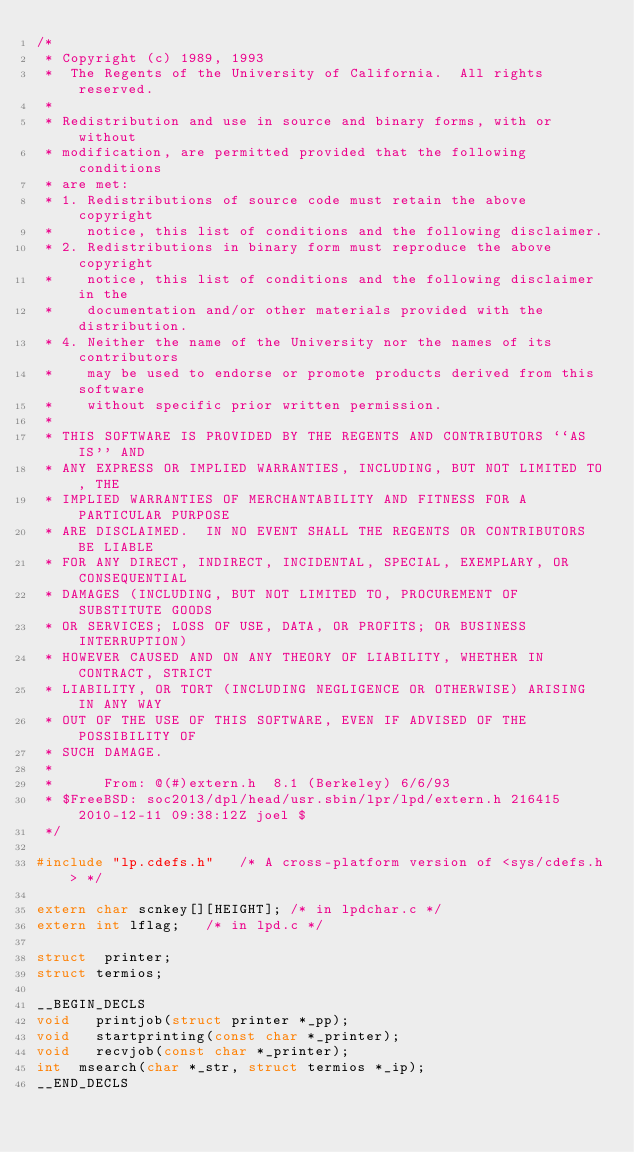Convert code to text. <code><loc_0><loc_0><loc_500><loc_500><_C_>/*
 * Copyright (c) 1989, 1993
 *	The Regents of the University of California.  All rights reserved.
 *
 * Redistribution and use in source and binary forms, with or without
 * modification, are permitted provided that the following conditions
 * are met:
 * 1. Redistributions of source code must retain the above copyright
 *    notice, this list of conditions and the following disclaimer.
 * 2. Redistributions in binary form must reproduce the above copyright
 *    notice, this list of conditions and the following disclaimer in the
 *    documentation and/or other materials provided with the distribution.
 * 4. Neither the name of the University nor the names of its contributors
 *    may be used to endorse or promote products derived from this software
 *    without specific prior written permission.
 *
 * THIS SOFTWARE IS PROVIDED BY THE REGENTS AND CONTRIBUTORS ``AS IS'' AND
 * ANY EXPRESS OR IMPLIED WARRANTIES, INCLUDING, BUT NOT LIMITED TO, THE
 * IMPLIED WARRANTIES OF MERCHANTABILITY AND FITNESS FOR A PARTICULAR PURPOSE
 * ARE DISCLAIMED.  IN NO EVENT SHALL THE REGENTS OR CONTRIBUTORS BE LIABLE
 * FOR ANY DIRECT, INDIRECT, INCIDENTAL, SPECIAL, EXEMPLARY, OR CONSEQUENTIAL
 * DAMAGES (INCLUDING, BUT NOT LIMITED TO, PROCUREMENT OF SUBSTITUTE GOODS
 * OR SERVICES; LOSS OF USE, DATA, OR PROFITS; OR BUSINESS INTERRUPTION)
 * HOWEVER CAUSED AND ON ANY THEORY OF LIABILITY, WHETHER IN CONTRACT, STRICT
 * LIABILITY, OR TORT (INCLUDING NEGLIGENCE OR OTHERWISE) ARISING IN ANY WAY
 * OUT OF THE USE OF THIS SOFTWARE, EVEN IF ADVISED OF THE POSSIBILITY OF
 * SUCH DAMAGE.
 *
 *      From: @(#)extern.h	8.1 (Berkeley) 6/6/93
 * $FreeBSD: soc2013/dpl/head/usr.sbin/lpr/lpd/extern.h 216415 2010-12-11 09:38:12Z joel $
 */

#include "lp.cdefs.h"		/* A cross-platform version of <sys/cdefs.h> */

extern char scnkey[][HEIGHT];	/* in lpdchar.c */
extern int lflag;		/* in lpd.c */

struct	printer;
struct termios;

__BEGIN_DECLS
void	 printjob(struct printer *_pp);
void	 startprinting(const char *_printer);
void	 recvjob(const char *_printer);
int	 msearch(char *_str, struct termios *_ip);
__END_DECLS
</code> 